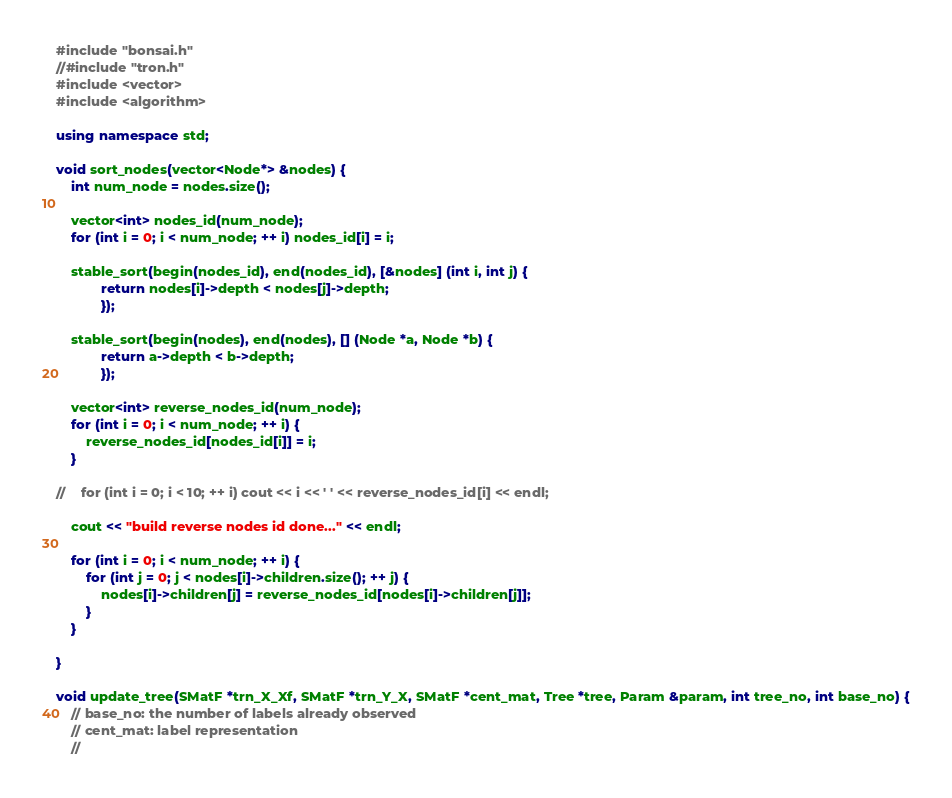<code> <loc_0><loc_0><loc_500><loc_500><_C++_>#include "bonsai.h"
//#include "tron.h"
#include <vector>
#include <algorithm>

using namespace std;

void sort_nodes(vector<Node*> &nodes) {
    int num_node = nodes.size();

    vector<int> nodes_id(num_node);
    for (int i = 0; i < num_node; ++ i) nodes_id[i] = i;

    stable_sort(begin(nodes_id), end(nodes_id), [&nodes] (int i, int j) {
            return nodes[i]->depth < nodes[j]->depth;
            });

    stable_sort(begin(nodes), end(nodes), [] (Node *a, Node *b) {
            return a->depth < b->depth;
            });

    vector<int> reverse_nodes_id(num_node);
    for (int i = 0; i < num_node; ++ i) {
        reverse_nodes_id[nodes_id[i]] = i;
    }

//    for (int i = 0; i < 10; ++ i) cout << i << ' ' << reverse_nodes_id[i] << endl;

    cout << "build reverse nodes id done..." << endl;

    for (int i = 0; i < num_node; ++ i) {
        for (int j = 0; j < nodes[i]->children.size(); ++ j) {
            nodes[i]->children[j] = reverse_nodes_id[nodes[i]->children[j]];
        }
    }

}

void update_tree(SMatF *trn_X_Xf, SMatF *trn_Y_X, SMatF *cent_mat, Tree *tree, Param &param, int tree_no, int base_no) {
    // base_no: the number of labels already observed
    // cent_mat: label representation
    //</code> 